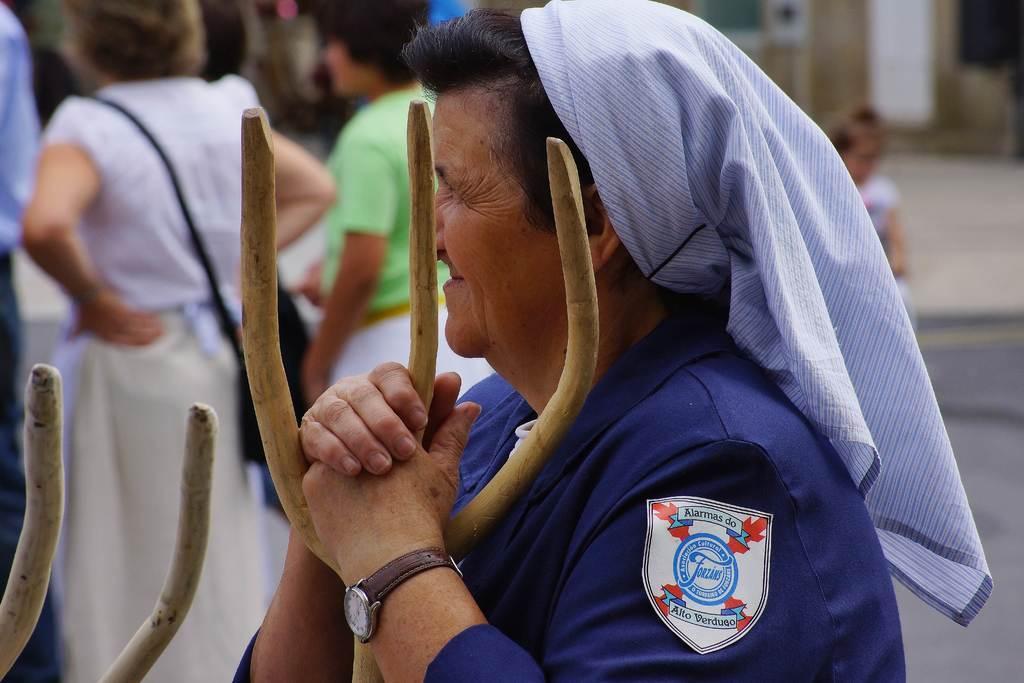Can you describe this image briefly? In this picture we can see a woman wore a watch and holding a wooden stick with her hands and in the background we can see a group of people on the road and it is blurry. 